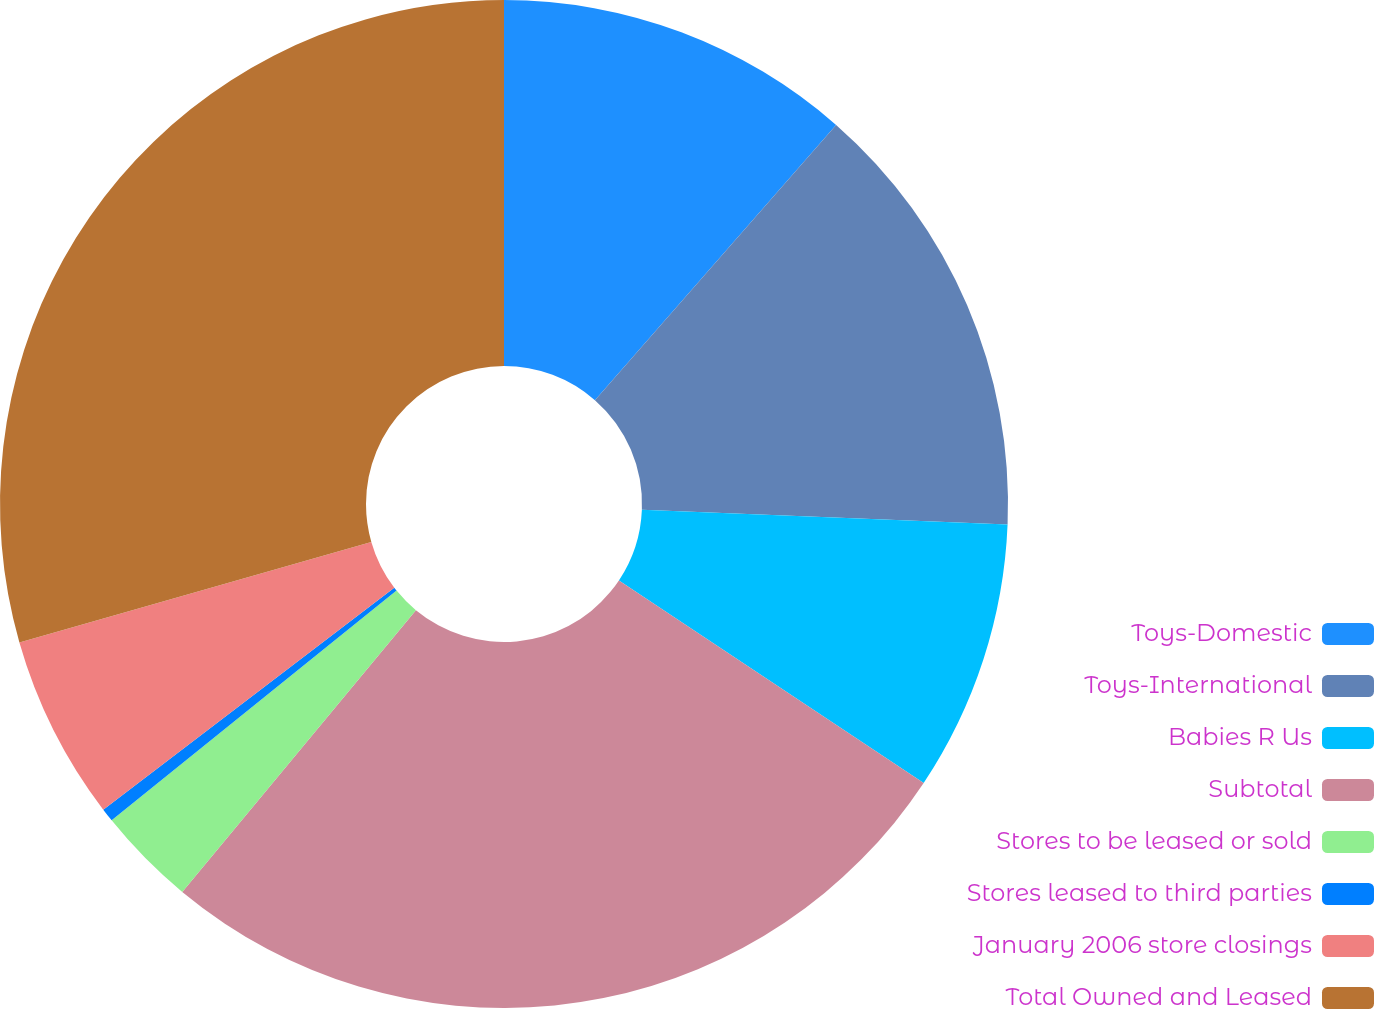<chart> <loc_0><loc_0><loc_500><loc_500><pie_chart><fcel>Toys-Domestic<fcel>Toys-International<fcel>Babies R Us<fcel>Subtotal<fcel>Stores to be leased or sold<fcel>Stores leased to third parties<fcel>January 2006 store closings<fcel>Total Owned and Leased<nl><fcel>11.45%<fcel>14.2%<fcel>8.69%<fcel>26.68%<fcel>3.18%<fcel>0.43%<fcel>5.94%<fcel>29.43%<nl></chart> 